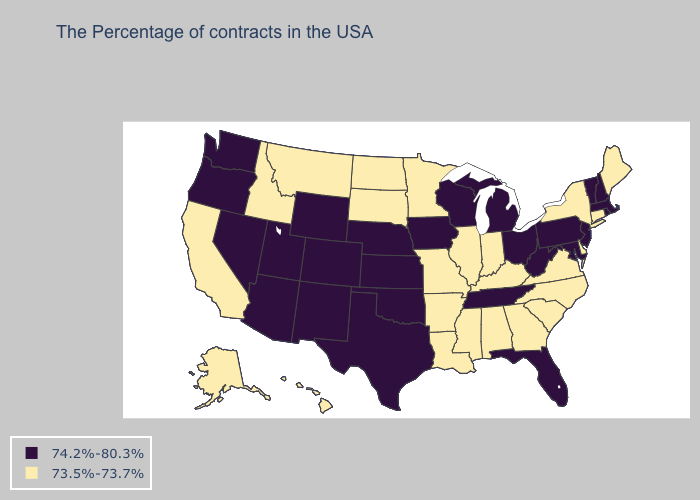What is the lowest value in the USA?
Short answer required. 73.5%-73.7%. Does Hawaii have the lowest value in the USA?
Write a very short answer. Yes. Does the first symbol in the legend represent the smallest category?
Give a very brief answer. No. How many symbols are there in the legend?
Give a very brief answer. 2. Among the states that border North Dakota , which have the highest value?
Answer briefly. Minnesota, South Dakota, Montana. What is the lowest value in the USA?
Short answer required. 73.5%-73.7%. What is the value of Virginia?
Keep it brief. 73.5%-73.7%. Does California have a lower value than West Virginia?
Answer briefly. Yes. Does Colorado have a lower value than Louisiana?
Short answer required. No. Does North Carolina have the same value as Wyoming?
Short answer required. No. Name the states that have a value in the range 73.5%-73.7%?
Answer briefly. Maine, Connecticut, New York, Delaware, Virginia, North Carolina, South Carolina, Georgia, Kentucky, Indiana, Alabama, Illinois, Mississippi, Louisiana, Missouri, Arkansas, Minnesota, South Dakota, North Dakota, Montana, Idaho, California, Alaska, Hawaii. Which states have the lowest value in the USA?
Quick response, please. Maine, Connecticut, New York, Delaware, Virginia, North Carolina, South Carolina, Georgia, Kentucky, Indiana, Alabama, Illinois, Mississippi, Louisiana, Missouri, Arkansas, Minnesota, South Dakota, North Dakota, Montana, Idaho, California, Alaska, Hawaii. Which states have the highest value in the USA?
Short answer required. Massachusetts, Rhode Island, New Hampshire, Vermont, New Jersey, Maryland, Pennsylvania, West Virginia, Ohio, Florida, Michigan, Tennessee, Wisconsin, Iowa, Kansas, Nebraska, Oklahoma, Texas, Wyoming, Colorado, New Mexico, Utah, Arizona, Nevada, Washington, Oregon. Name the states that have a value in the range 74.2%-80.3%?
Write a very short answer. Massachusetts, Rhode Island, New Hampshire, Vermont, New Jersey, Maryland, Pennsylvania, West Virginia, Ohio, Florida, Michigan, Tennessee, Wisconsin, Iowa, Kansas, Nebraska, Oklahoma, Texas, Wyoming, Colorado, New Mexico, Utah, Arizona, Nevada, Washington, Oregon. 